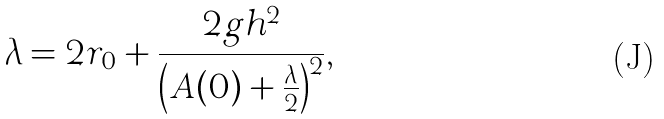Convert formula to latex. <formula><loc_0><loc_0><loc_500><loc_500>\lambda = 2 r _ { 0 } + \frac { 2 g h ^ { 2 } } { \left ( A ( 0 ) + \frac { \lambda } { 2 } \right ) ^ { 2 } } ,</formula> 